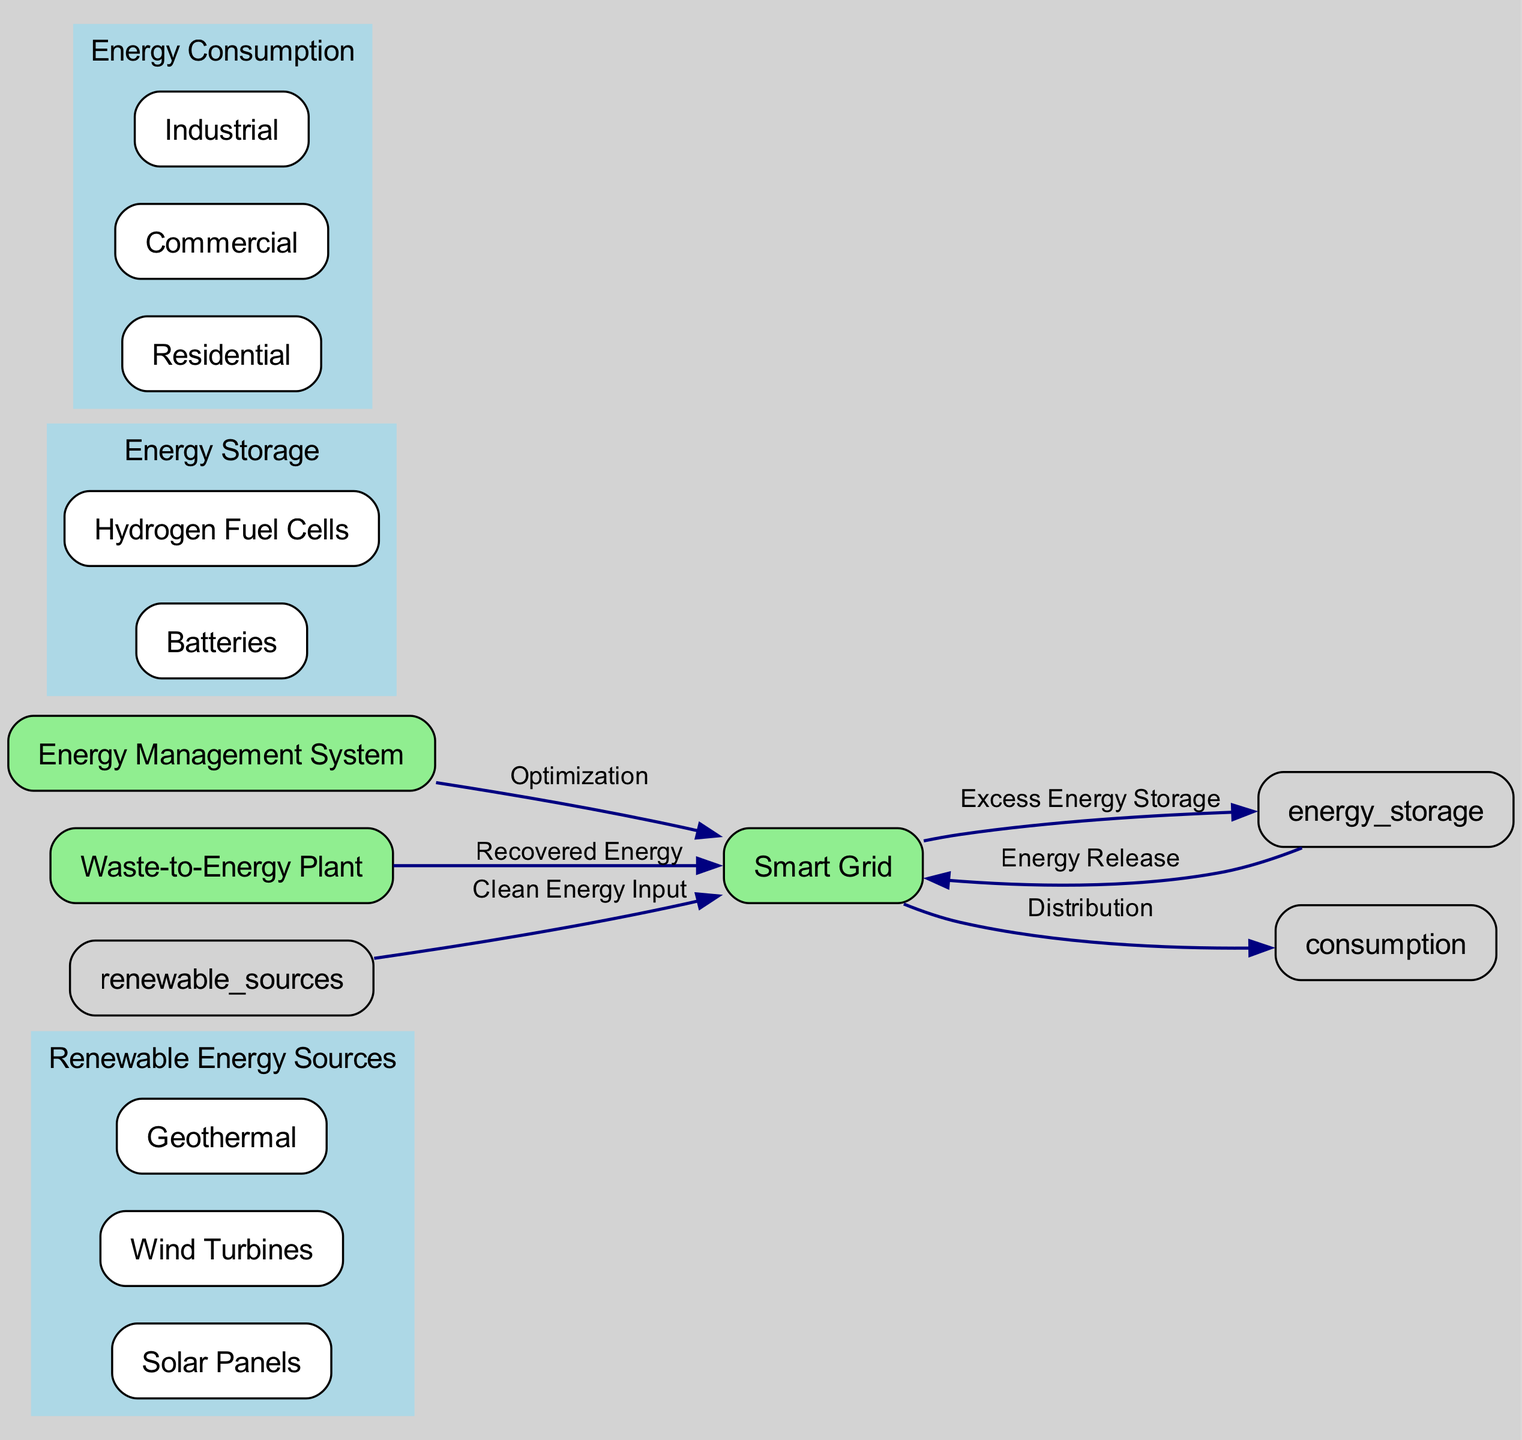What are the renewable energy sources listed in the diagram? The nodes for renewable energy sources show "Solar Panels", "Wind Turbines", and "Geothermal" as subnodes. These are mentioned explicitly under the "Renewable Energy Sources" node in the diagram.
Answer: Solar Panels, Wind Turbines, Geothermal How many edges are there in the diagram? The edges showing relationships between nodes include all connections from "Renewable Energy Sources" to "Smart Grid", and so on. Counting each unique directed connection, there are a total of six connections.
Answer: 6 Which node receives energy from the waste-to-energy plant? The diagram indicates that the edge labeled "Recovered Energy" connects the "Waste-to-Energy Plant" to the "Smart Grid", meaning the Smart Grid receives energy from this plant.
Answer: Smart Grid What type of energy storage methods are shown in the diagram? The node labeled "Energy Storage" has subnodes "Batteries" and "Hydrogen Fuel Cells", defining the specific types of energy storage present in the diagram.
Answer: Batteries, Hydrogen Fuel Cells What is the function of the energy management system in the diagram? The "Energy Management System" node connects to the "Smart Grid" with the label "Optimization", indicating that its role is to optimize energy flows in the grid.
Answer: Optimization Which node distributes energy to consumption sectors? The edge labeled "Distribution" lines from the "Smart Grid" to the "Energy Consumption" node, showing that the Smart Grid handles the distribution of energy to various consumption sectors.
Answer: Energy Consumption How does excess energy from the smart grid get stored? The relationship between "Smart Grid" and "Energy Storage" is represented by the edge labeled "Excess Energy Storage", showing that the smart grid sends excess energy to be stored.
Answer: Energy Storage Which subnode falls under the consumption category related to industrial use? The "Energy Consumption" node includes subnodes "Residential", "Commercial", and "Industrial". The presence of "Industrial" indicates its specific inclusion under this category.
Answer: Industrial 